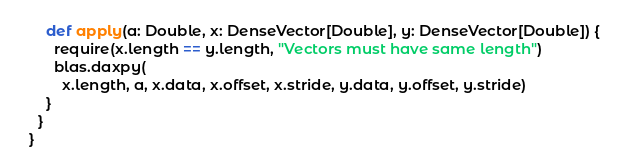Convert code to text. <code><loc_0><loc_0><loc_500><loc_500><_Scala_>      def apply(a: Double, x: DenseVector[Double], y: DenseVector[Double]) {
        require(x.length == y.length, "Vectors must have same length")
        blas.daxpy(
          x.length, a, x.data, x.offset, x.stride, y.data, y.offset, y.stride)
      }
    }
  }
</code> 